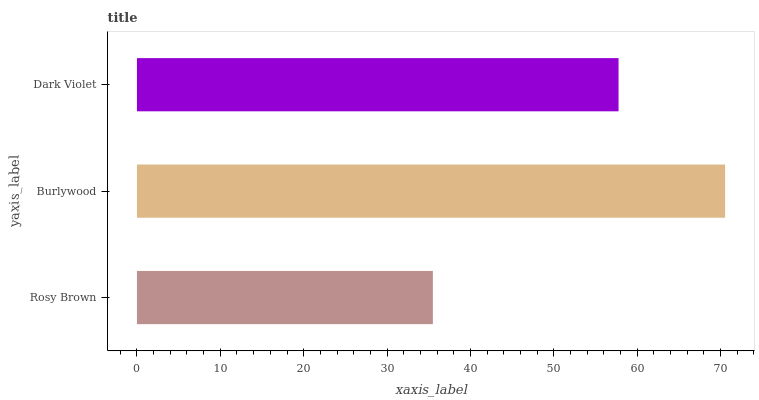Is Rosy Brown the minimum?
Answer yes or no. Yes. Is Burlywood the maximum?
Answer yes or no. Yes. Is Dark Violet the minimum?
Answer yes or no. No. Is Dark Violet the maximum?
Answer yes or no. No. Is Burlywood greater than Dark Violet?
Answer yes or no. Yes. Is Dark Violet less than Burlywood?
Answer yes or no. Yes. Is Dark Violet greater than Burlywood?
Answer yes or no. No. Is Burlywood less than Dark Violet?
Answer yes or no. No. Is Dark Violet the high median?
Answer yes or no. Yes. Is Dark Violet the low median?
Answer yes or no. Yes. Is Rosy Brown the high median?
Answer yes or no. No. Is Burlywood the low median?
Answer yes or no. No. 